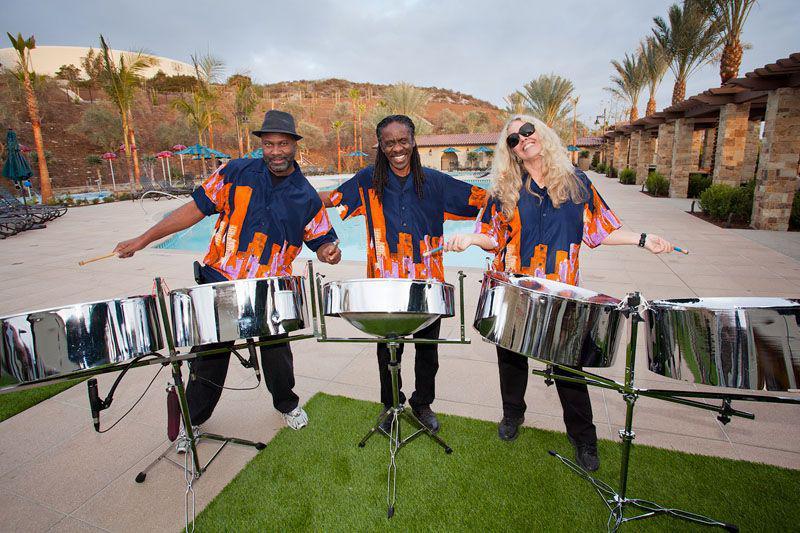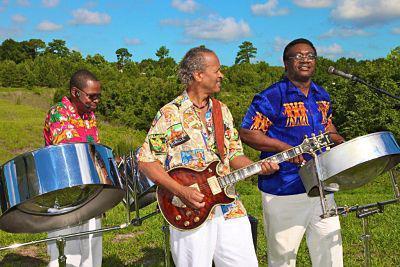The first image is the image on the left, the second image is the image on the right. Considering the images on both sides, is "In one image all the musicians are wearing hats." valid? Answer yes or no. No. The first image is the image on the left, the second image is the image on the right. For the images shown, is this caption "One image features three men in hats and leis and hawaiian shirts standing behind silver metal drums on pivoting stands." true? Answer yes or no. No. 